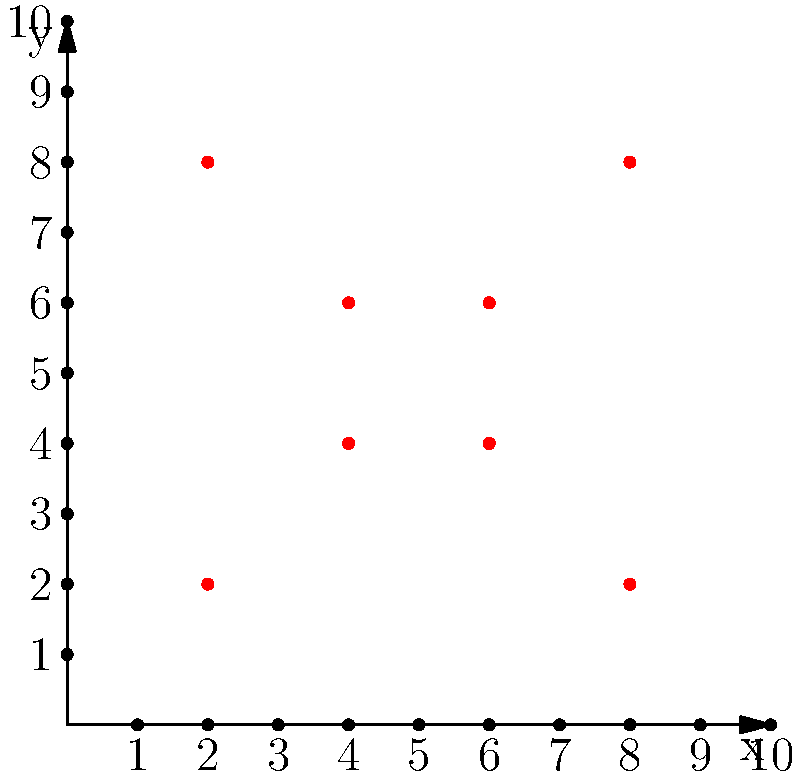As a history enthusiast planning a vintage-themed wedding, you want to recreate a classic Art Deco design for your invitation. The design consists of a symmetrical pattern that can be plotted on a coordinate plane. Given the coordinates (2,8), (4,6), (6,6), (8,8), (8,2), (6,4), (4,4), and (2,2), what geometric shape will be formed when these points are connected in the order given? Let's approach this step-by-step:

1. Plot the given points on the coordinate plane:
   (2,8), (4,6), (6,6), (8,8), (8,2), (6,4), (4,4), (2,2)

2. Connect these points in the order given:
   - Start at (2,8)
   - Draw a line to (4,6)
   - Continue to (6,6)
   - Then to (8,8)
   - Down to (8,2)
   - To (6,4)
   - Then (4,4)
   - Finally, back to (2,2)

3. Analyze the shape:
   - The shape has 8 vertices
   - It's symmetrical along a vertical line passing through x = 5
   - The top and bottom portions mirror each other
   - All angles appear to be either right angles (90°) or 45° angles

4. Recognize the shape:
   - This forms an octagon, which is a polygon with 8 sides and 8 vertices
   - More specifically, it's a special type of octagon known as a "concave octagon" or "hourglass octagon" due to its inward curves at the middle

5. Historical context:
   - This hourglass octagon shape was popular in Art Deco designs, which fits perfectly with a vintage-themed wedding from the 1920s or 1930s era

Therefore, when these points are connected in the given order, they form a concave or hourglass octagon, a shape characteristic of Art Deco design.
Answer: Concave (hourglass) octagon 